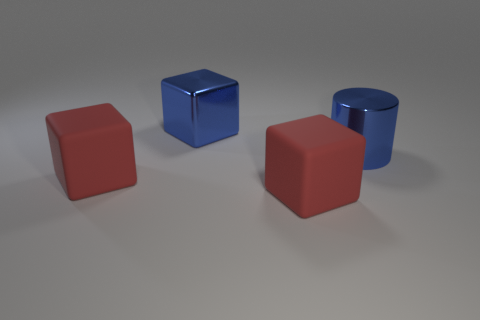Add 3 large red blocks. How many objects exist? 7 Subtract all cylinders. How many objects are left? 3 Subtract all big red cubes. Subtract all blue metal cylinders. How many objects are left? 1 Add 2 large metal things. How many large metal things are left? 4 Add 4 big rubber things. How many big rubber things exist? 6 Subtract 0 gray cylinders. How many objects are left? 4 